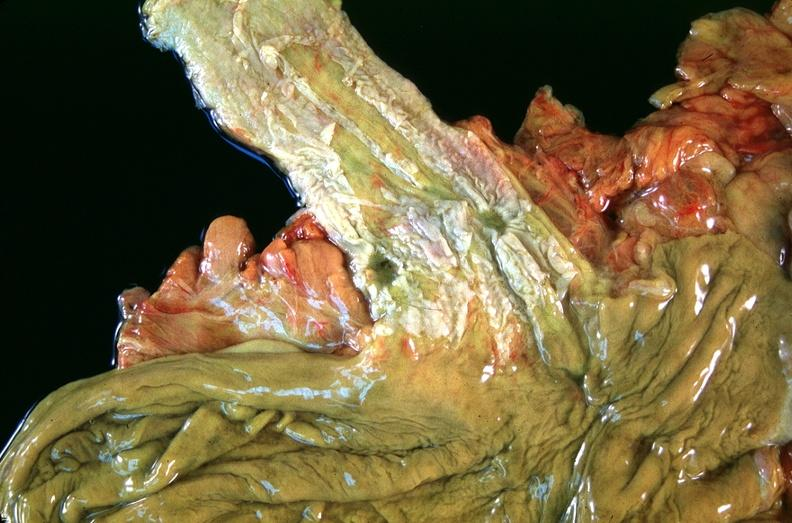what is present?
Answer the question using a single word or phrase. Gastrointestinal 